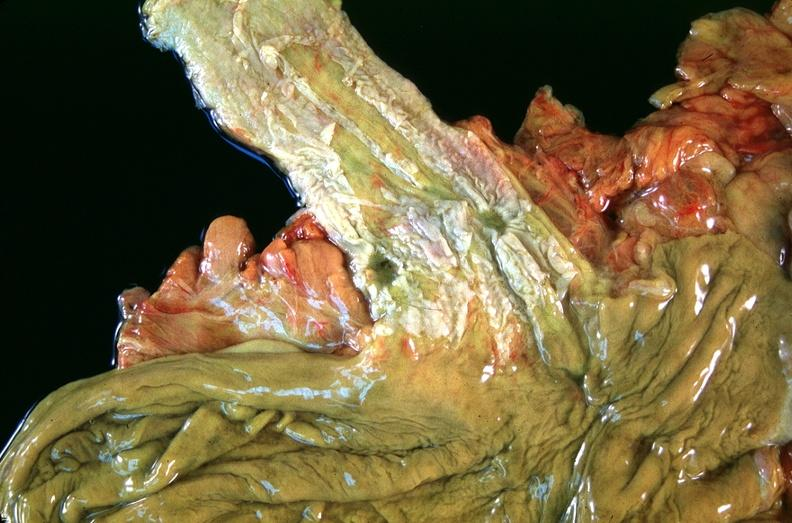what is present?
Answer the question using a single word or phrase. Gastrointestinal 